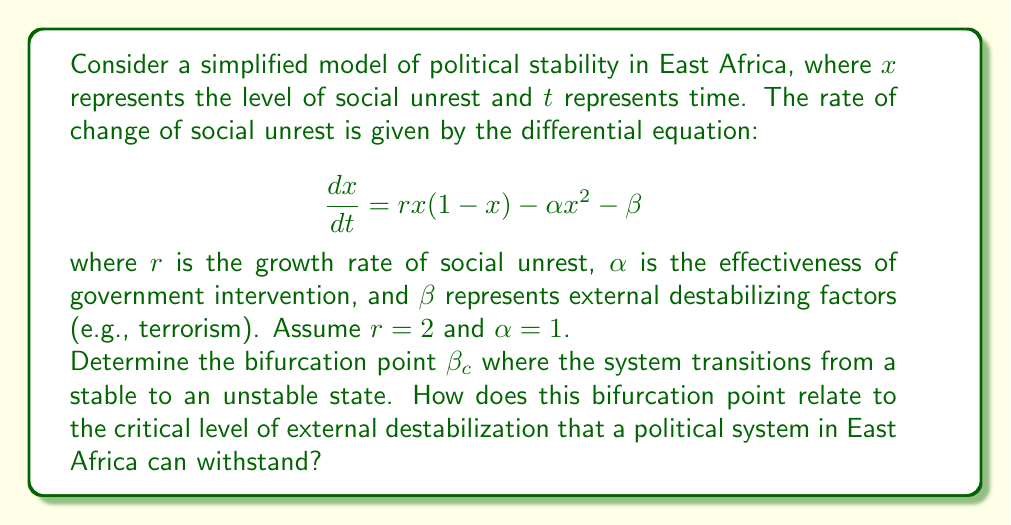Can you answer this question? To solve this problem, we'll follow these steps:

1) First, we need to find the equilibrium points of the system. These are the points where $\frac{dx}{dt} = 0$. So we set up the equation:

   $$rx(1-x) - \alpha x^2 - \beta = 0$$

2) Substituting the given values $r=2$ and $\alpha=1$:

   $$2x(1-x) - x^2 - \beta = 0$$

3) Simplify:

   $$2x - 2x^2 - x^2 - \beta = 0$$
   $$2x - 3x^2 - \beta = 0$$

4) This is a quadratic equation in $x$. For a bifurcation to occur, this equation should have exactly one solution (a tangent point). This happens when the discriminant of the quadratic equation is zero.

5) The general form of a quadratic equation is $ax^2 + bx + c = 0$. In our case:
   $a = -3$, $b = 2$, and $c = -\beta$

6) The discriminant is given by $b^2 - 4ac$. Setting this to zero:

   $$b^2 - 4ac = 0$$
   $$2^2 - 4(-3)(-\beta) = 0$$
   $$4 - 12\beta = 0$$

7) Solve for $\beta$:

   $$12\beta = 4$$
   $$\beta = \frac{1}{3}$$

8) Therefore, the bifurcation point $\beta_c = \frac{1}{3}$

This bifurcation point represents the critical level of external destabilization. When $\beta < \frac{1}{3}$, the system has two equilibrium points, one stable and one unstable. When $\beta > \frac{1}{3}$, there are no real equilibrium points, indicating a highly unstable system. At $\beta = \frac{1}{3}$, the system is at a tipping point between these two states.
Answer: $\beta_c = \frac{1}{3}$ 